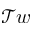<formula> <loc_0><loc_0><loc_500><loc_500>\mathcal { T } w</formula> 